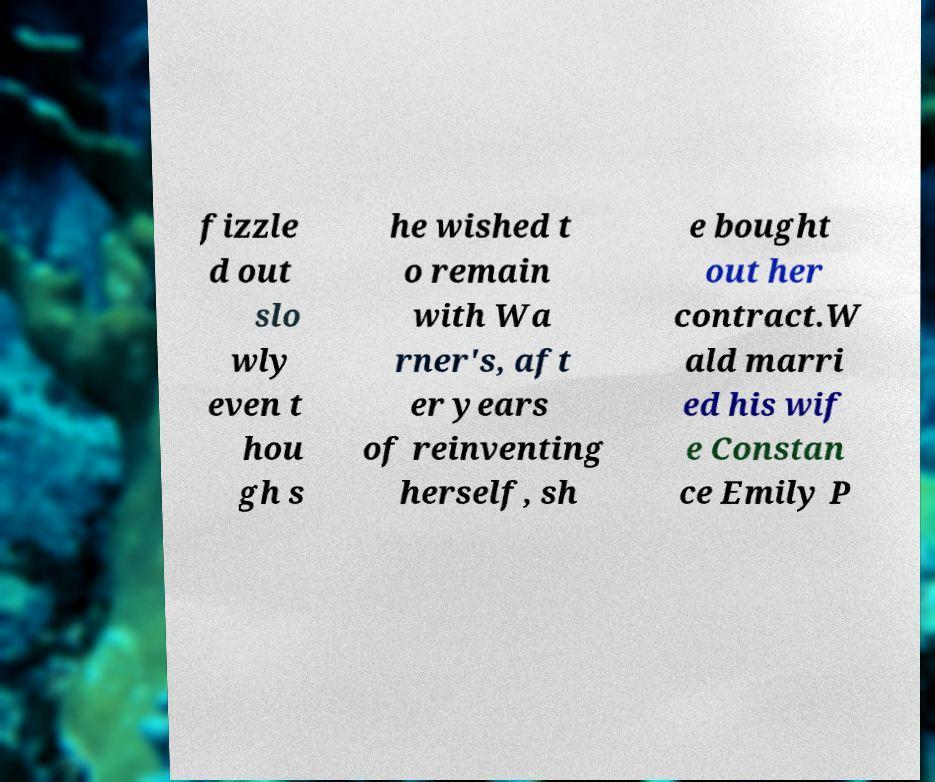Could you assist in decoding the text presented in this image and type it out clearly? fizzle d out slo wly even t hou gh s he wished t o remain with Wa rner's, aft er years of reinventing herself, sh e bought out her contract.W ald marri ed his wif e Constan ce Emily P 